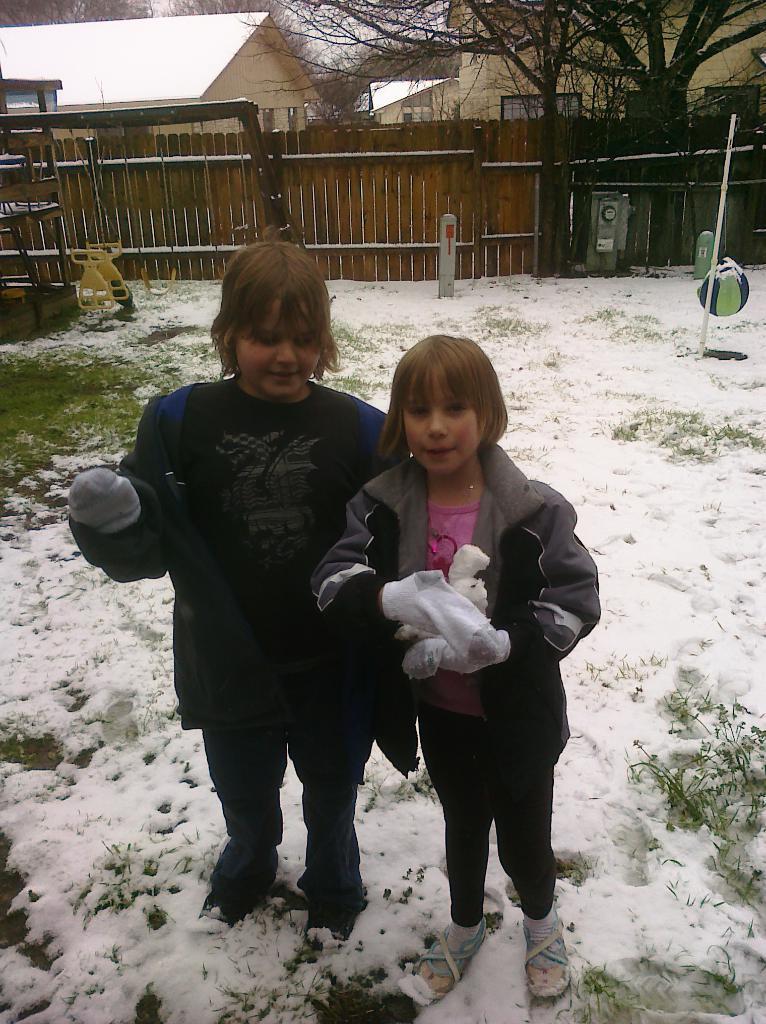Please provide a concise description of this image. In this picture there are two kids wearing jackets are standing on the snow and there is a wooden fence,trees and few houses in the background. 